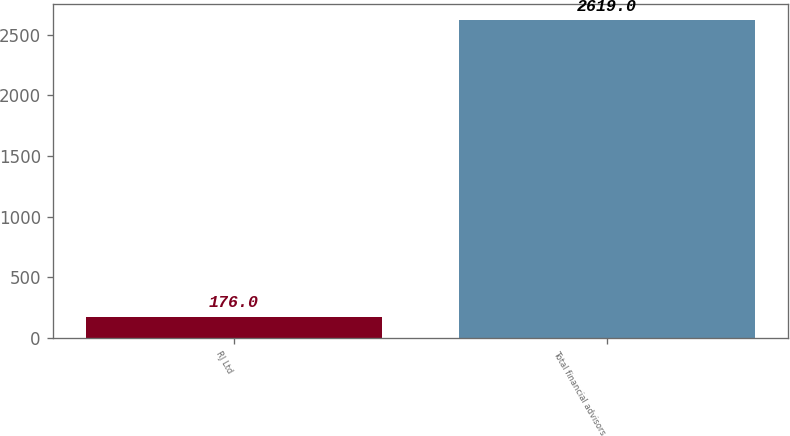Convert chart to OTSL. <chart><loc_0><loc_0><loc_500><loc_500><bar_chart><fcel>RJ Ltd<fcel>Total financial advisors<nl><fcel>176<fcel>2619<nl></chart> 